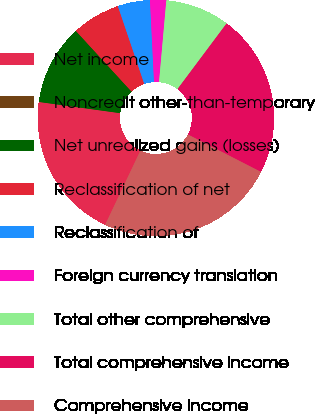<chart> <loc_0><loc_0><loc_500><loc_500><pie_chart><fcel>Net income<fcel>Noncredit other-than-temporary<fcel>Net unrealized gains (losses)<fcel>Reclassification of net<fcel>Reclassification of<fcel>Foreign currency translation<fcel>Total other comprehensive<fcel>Total comprehensive income<fcel>Comprehensive income<nl><fcel>20.12%<fcel>0.01%<fcel>11.0%<fcel>6.61%<fcel>4.41%<fcel>2.21%<fcel>8.8%<fcel>22.32%<fcel>24.52%<nl></chart> 